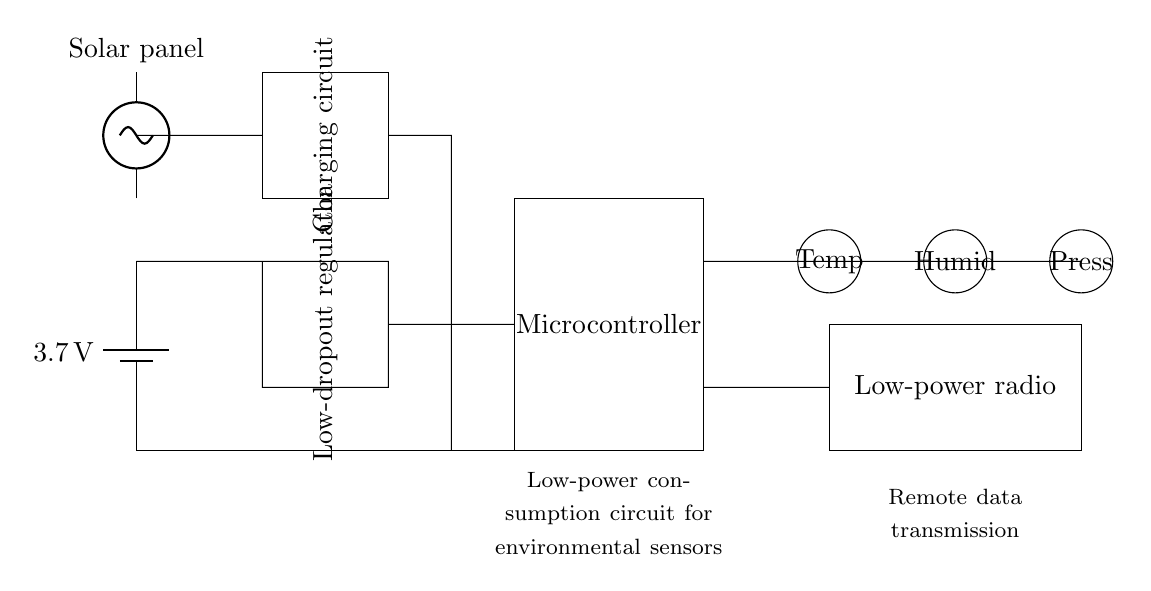what is the voltage of the battery in the circuit? The battery is labeled as providing a voltage of 3.7 volts; this is indicated directly on the battery symbol in the circuit diagram.
Answer: 3.7 volts what type of regulator is used in this circuit? The circuit shows a rectangle labeled as a "Low-dropout regulator," indicating the type of voltage regulator implemented to maintain a stable output voltage while consuming less power.
Answer: Low-dropout regulator how many sensors are connected in the circuit? There are three sensors depicted in the diagram, labeled as "Temp," "Humid," and "Press," and they are arranged in a sequence connected to the microcontroller.
Answer: three what is the function of the solar panel in this circuit? The solar panel is connected at the top of the circuit and is labeled as a "Solar panel," signifying its role in providing renewable energy to power the circuit components.
Answer: power source which component is responsible for radio communication? The component labeled as "Low-power radio" is specifically designed for communication, suggesting its function is to transmit data wirelessly from the environmental sensors.
Answer: Low-power radio what type of energy source recharges the battery in this circuit? The circuit depicts a "Charging circuit" connected to the solar panel, indicating that the battery is recharged using solar energy, which is renewable and suitable for remote locations.
Answer: solar energy what is the purpose of the microcontroller in the circuit? The microcontroller, marked in the diagram, serves as the central processing unit that manages data collection from the sensors and controls communication via the low-power radio, allowing it to process and transmit sensor data.
Answer: data management 